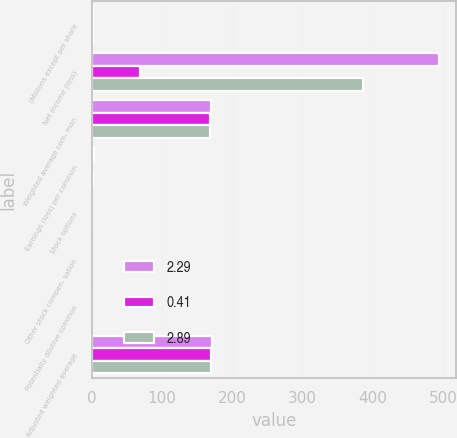Convert chart. <chart><loc_0><loc_0><loc_500><loc_500><stacked_bar_chart><ecel><fcel>(Millions except per share<fcel>Net income (loss)<fcel>Weighted average com- mon<fcel>Earnings (loss) per common<fcel>Stock options<fcel>Other stock compen- sation<fcel>Potentially dilutive common<fcel>Adjusted weighted average<nl><fcel>2.29<fcel>2.3<fcel>494<fcel>169.9<fcel>2.91<fcel>0.2<fcel>0.8<fcel>1<fcel>170.9<nl><fcel>0.41<fcel>2.3<fcel>69<fcel>169.1<fcel>0.41<fcel>0.2<fcel>0.6<fcel>0.8<fcel>169.9<nl><fcel>2.89<fcel>2.3<fcel>387<fcel>168.3<fcel>2.3<fcel>0.2<fcel>0.7<fcel>0.9<fcel>169.2<nl></chart> 